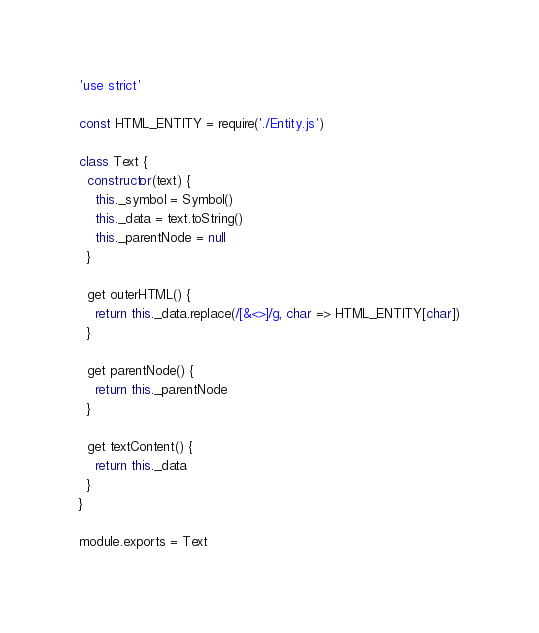<code> <loc_0><loc_0><loc_500><loc_500><_JavaScript_>'use strict'

const HTML_ENTITY = require('./Entity.js')

class Text {
  constructor(text) {
    this._symbol = Symbol()
    this._data = text.toString()
    this._parentNode = null
  }

  get outerHTML() {
    return this._data.replace(/[&<>]/g, char => HTML_ENTITY[char])
  }

  get parentNode() {
    return this._parentNode
  }

  get textContent() {
    return this._data
  }
}

module.exports = Text
</code> 